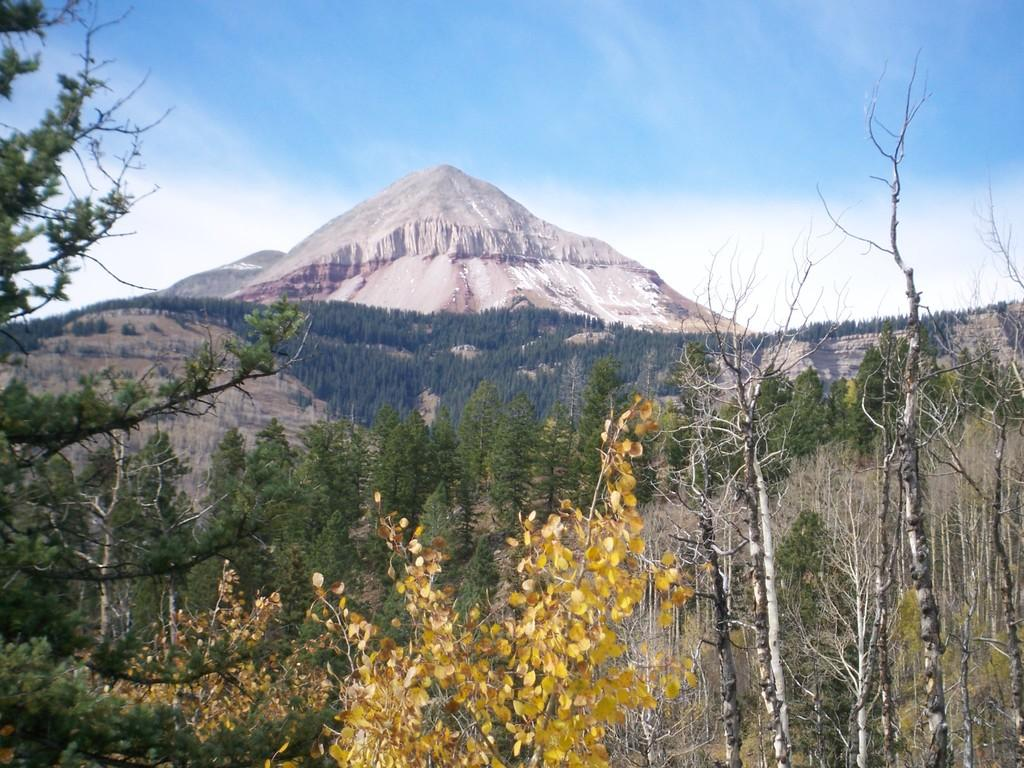What type of vegetation can be seen in the image? There is a group of trees in the image. What geographical features are visible in the image? There are hills visible in the image. What part of the natural environment is visible in the image? The sky is visible in the image. How would you describe the weather based on the appearance of the sky? The sky appears to be cloudy in the image. What type of treatment is being administered to the trees in the image? There is no treatment being administered to the trees in the image; they are simply standing in their natural environment. How does the society depicted in the image interact with the trees? There is no society depicted in the image, only trees, hills, and the sky. Can you see any quills in the image? There are no quills present in the image. 